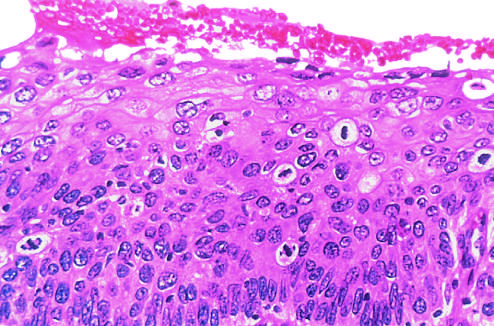what shows failure of normal differentiation, marked nuclear and cellular pleomorphism, and numerous mitotic figures extending toward the surface?
Answer the question using a single word or phrase. High-power view of another region 